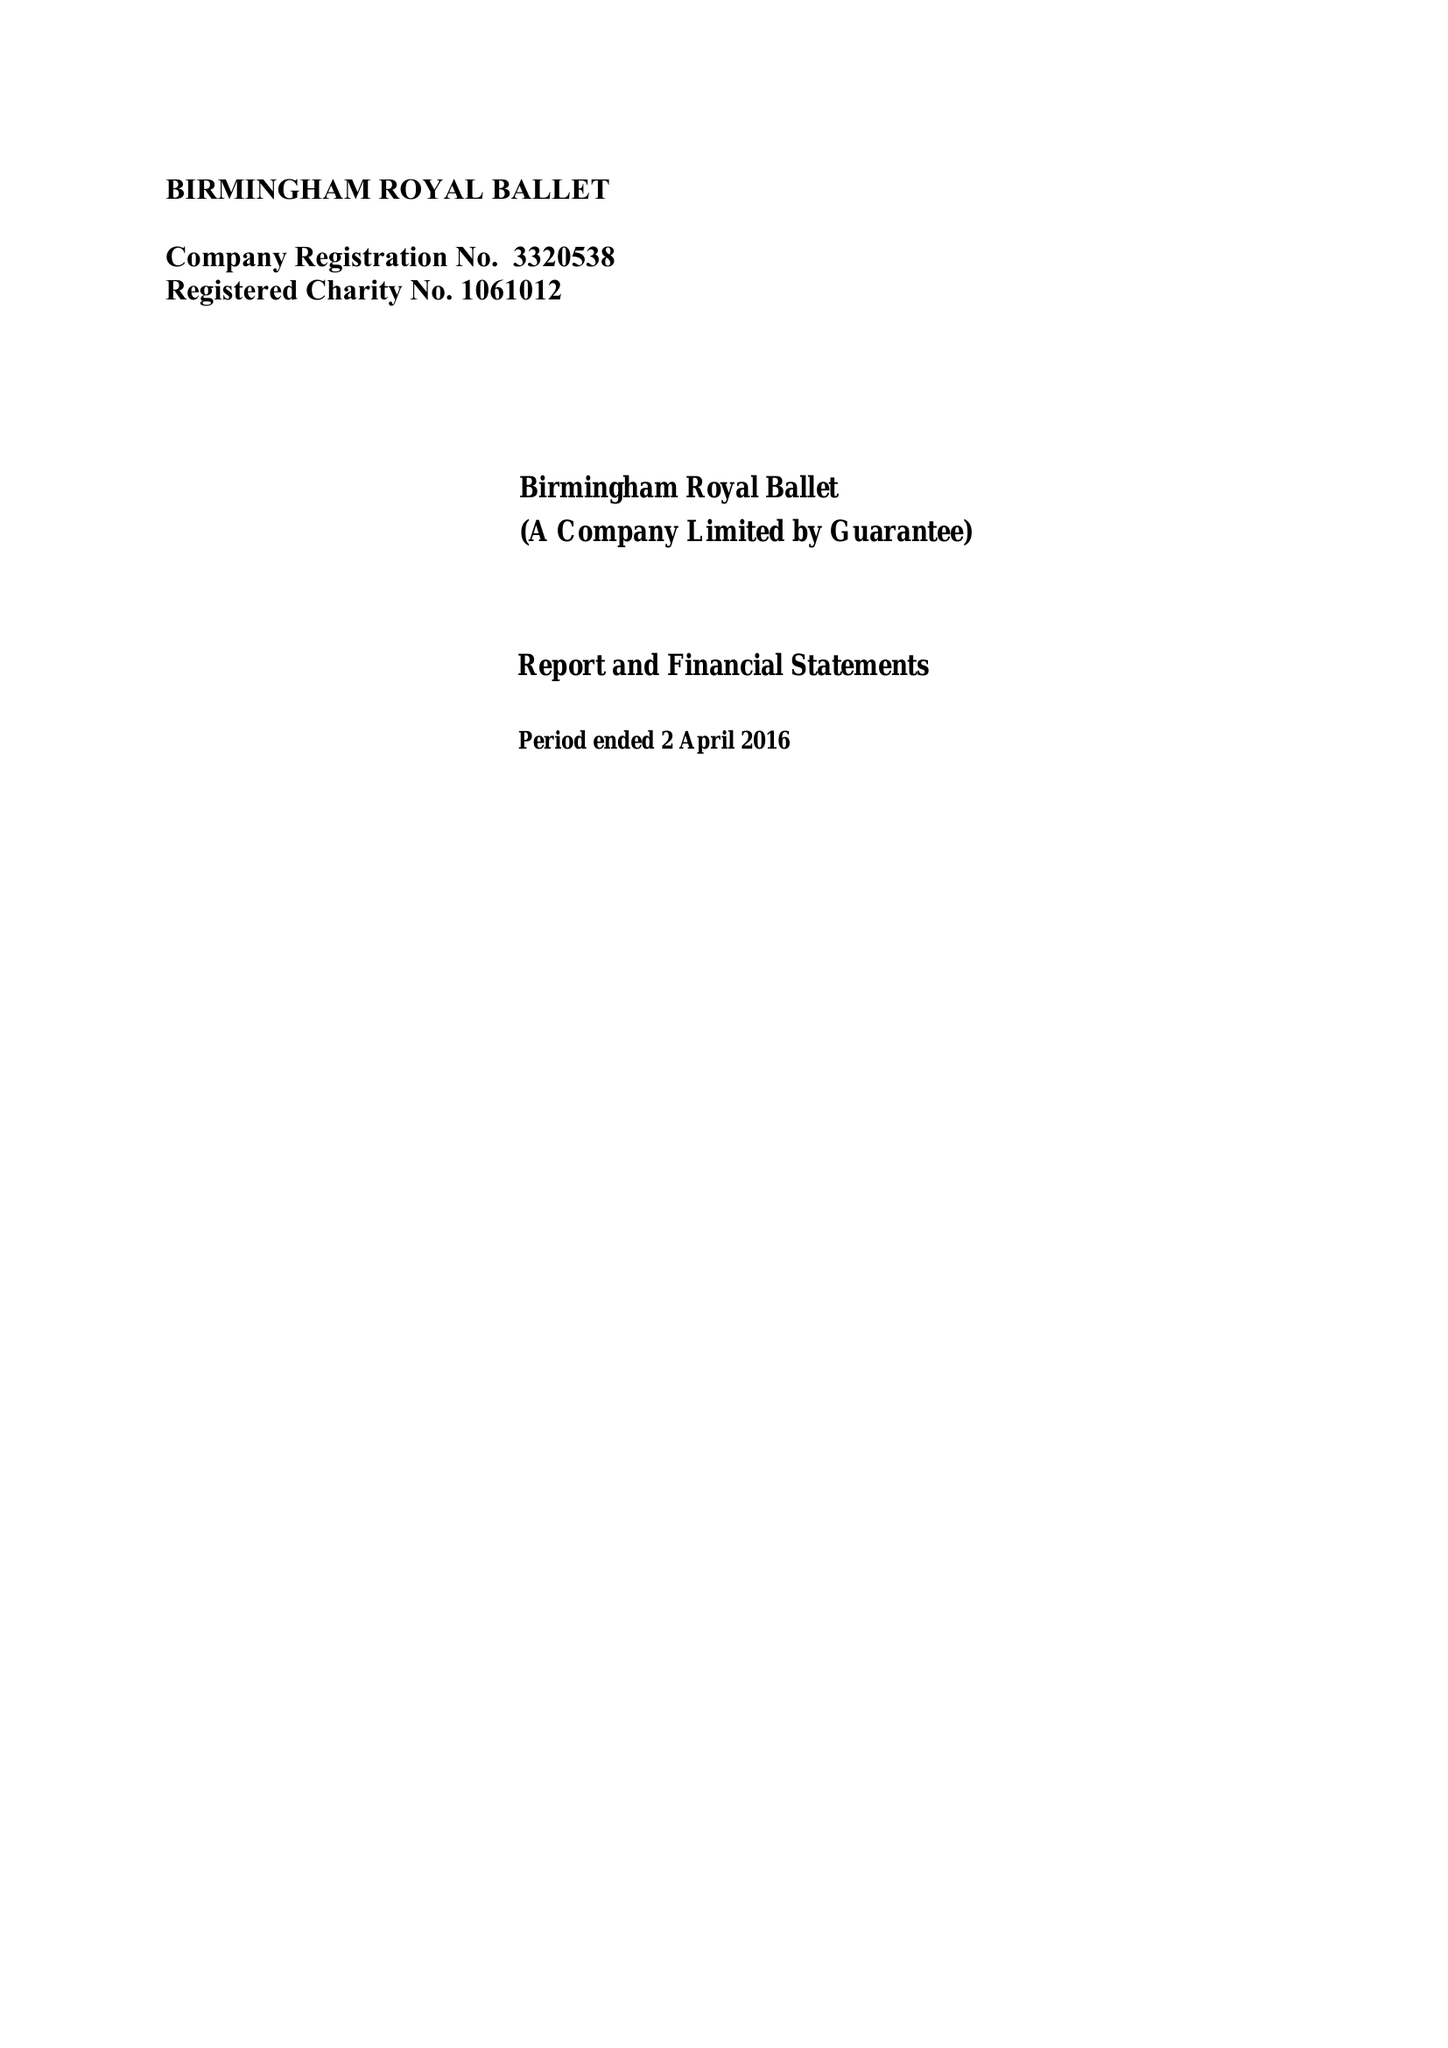What is the value for the report_date?
Answer the question using a single word or phrase. 2016-04-02 